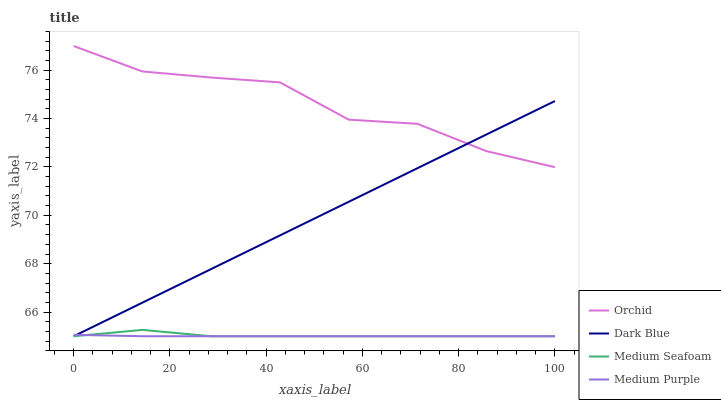Does Medium Purple have the minimum area under the curve?
Answer yes or no. Yes. Does Orchid have the maximum area under the curve?
Answer yes or no. Yes. Does Dark Blue have the minimum area under the curve?
Answer yes or no. No. Does Dark Blue have the maximum area under the curve?
Answer yes or no. No. Is Dark Blue the smoothest?
Answer yes or no. Yes. Is Orchid the roughest?
Answer yes or no. Yes. Is Medium Seafoam the smoothest?
Answer yes or no. No. Is Medium Seafoam the roughest?
Answer yes or no. No. Does Medium Purple have the lowest value?
Answer yes or no. Yes. Does Orchid have the lowest value?
Answer yes or no. No. Does Orchid have the highest value?
Answer yes or no. Yes. Does Dark Blue have the highest value?
Answer yes or no. No. Is Medium Purple less than Orchid?
Answer yes or no. Yes. Is Orchid greater than Medium Seafoam?
Answer yes or no. Yes. Does Dark Blue intersect Medium Seafoam?
Answer yes or no. Yes. Is Dark Blue less than Medium Seafoam?
Answer yes or no. No. Is Dark Blue greater than Medium Seafoam?
Answer yes or no. No. Does Medium Purple intersect Orchid?
Answer yes or no. No. 